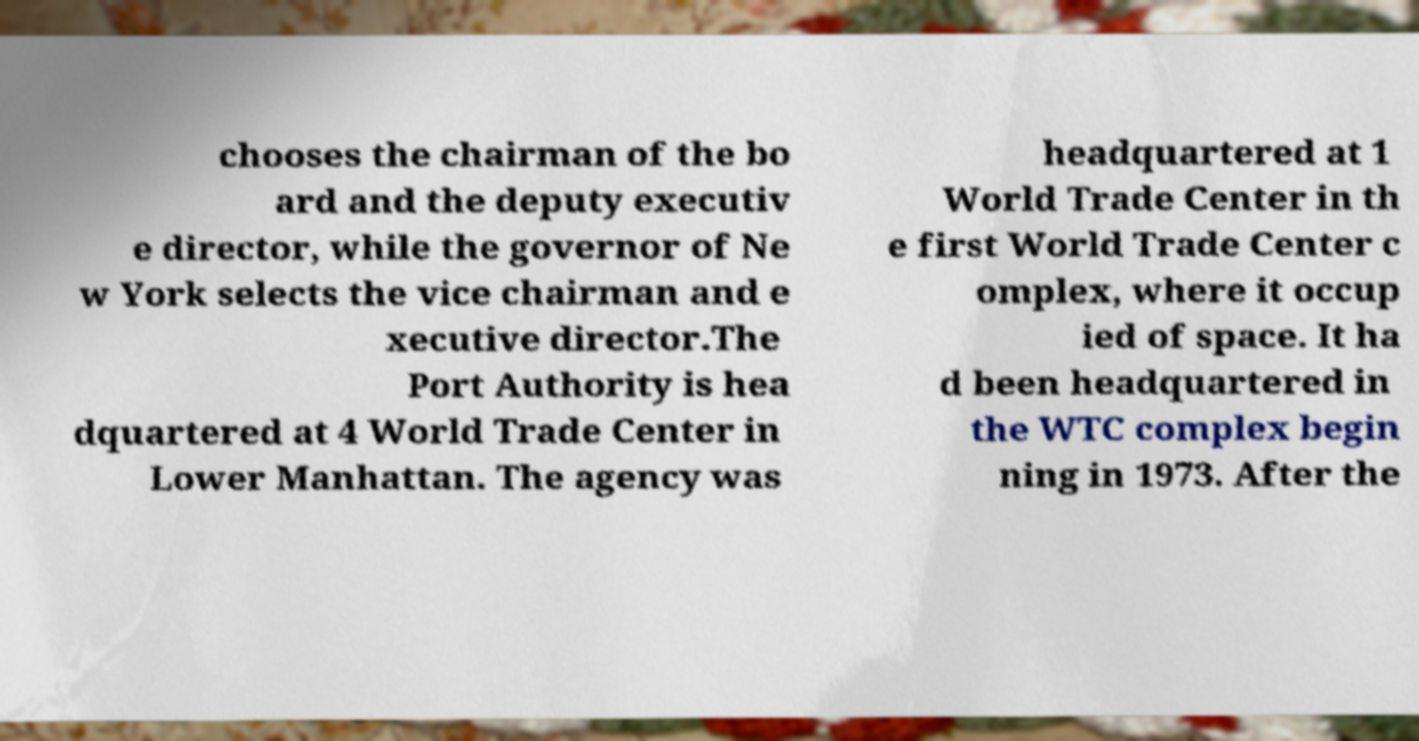Could you extract and type out the text from this image? chooses the chairman of the bo ard and the deputy executiv e director, while the governor of Ne w York selects the vice chairman and e xecutive director.The Port Authority is hea dquartered at 4 World Trade Center in Lower Manhattan. The agency was headquartered at 1 World Trade Center in th e first World Trade Center c omplex, where it occup ied of space. It ha d been headquartered in the WTC complex begin ning in 1973. After the 